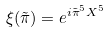Convert formula to latex. <formula><loc_0><loc_0><loc_500><loc_500>\xi ( \tilde { \pi } ) = e ^ { i \tilde { \pi } ^ { 5 } X ^ { 5 } }</formula> 